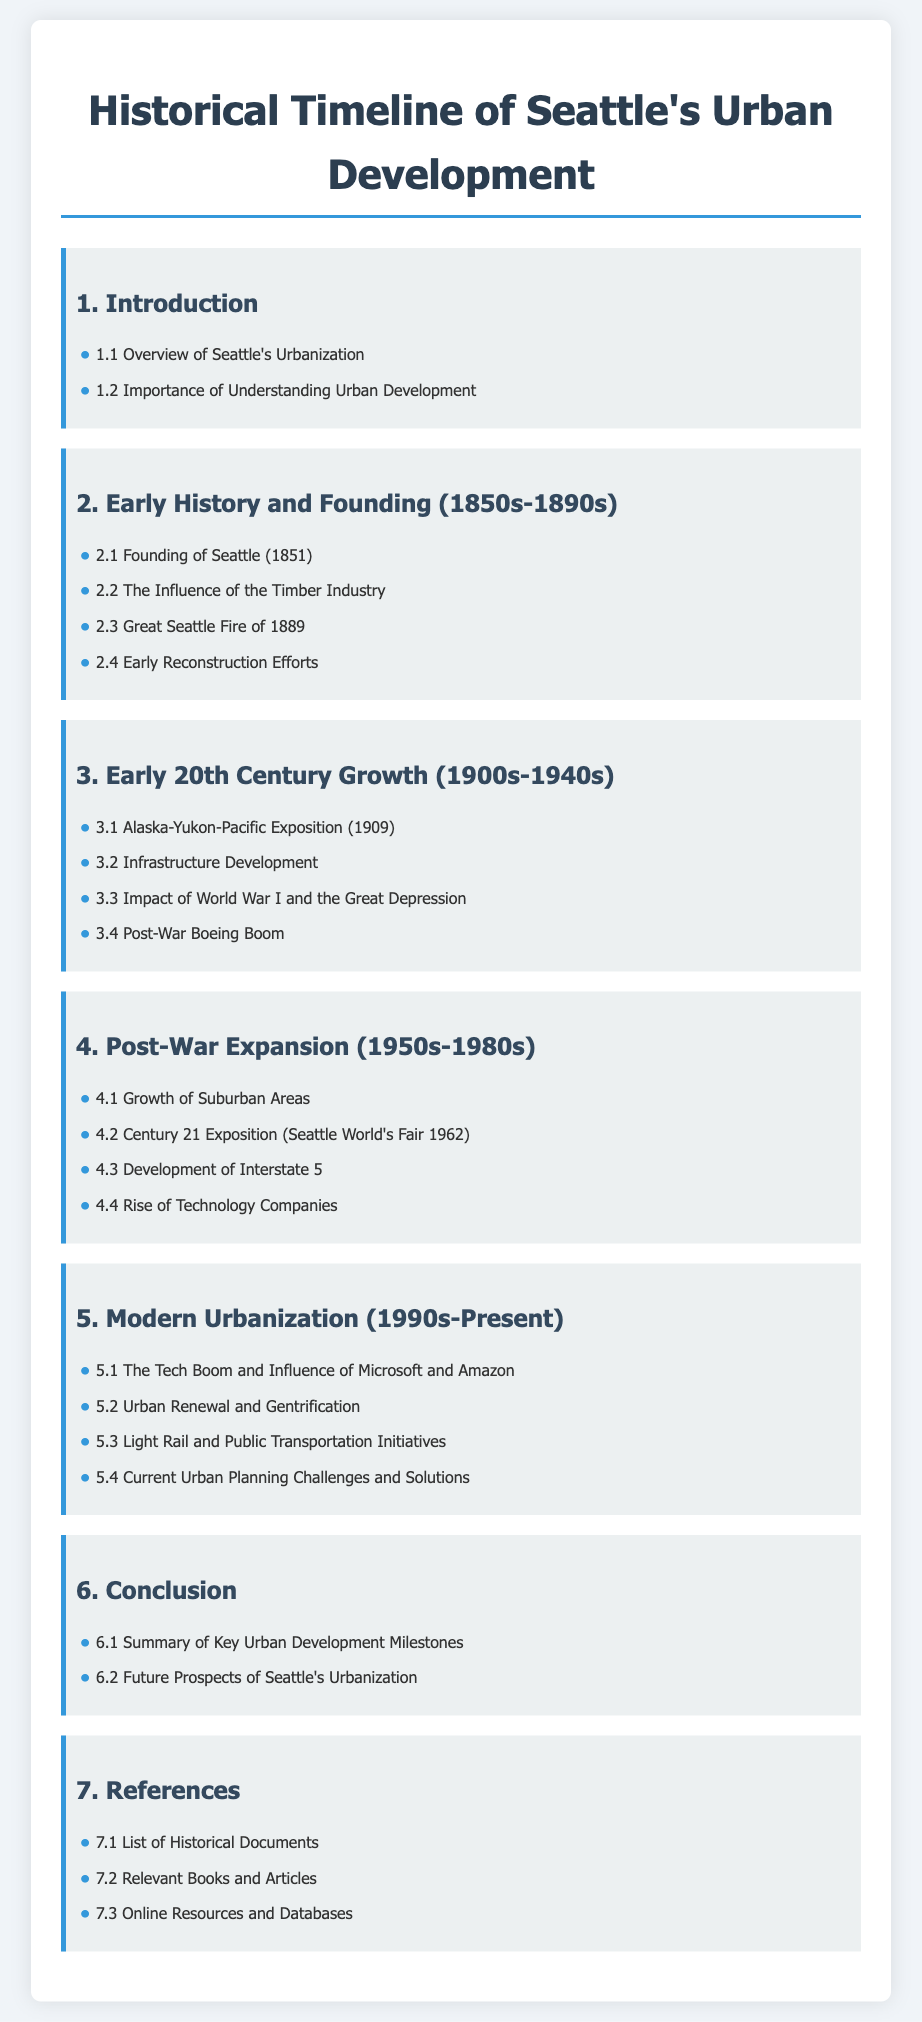What year was Seattle founded? The founding of Seattle occurred in the year detailed in the document.
Answer: 1851 What major event occurred in Seattle in 1889? The document mentions a significant disaster that took place in this year.
Answer: Great Seattle Fire What exposition took place in 1909? This event is referenced in the section related to early 20th-century growth.
Answer: Alaska-Yukon-Pacific Exposition What was a key event during the 1962 Seattle World's Fair? The document states the name of the exposition held during this year.
Answer: Century 21 Exposition Which companies influenced Seattle's tech boom in the 1990s? This section notes major companies impacting the city's urbanization.
Answer: Microsoft and Amazon What infrastructure development occurred during the post-war period? The document indicates a major highway associated with this era.
Answer: Interstate 5 What are the two main urban challenges mentioned for Seattle's present day? This section lists ongoing issues affecting the city's urban landscape.
Answer: Urban Renewal and Gentrification What decade did the Light Rail initiatives begin? The document mentions initiatives under the modern urbanization section.
Answer: 1990s What type of documents are included in the reference section? The references include a specific category of published material.
Answer: Historical Documents 